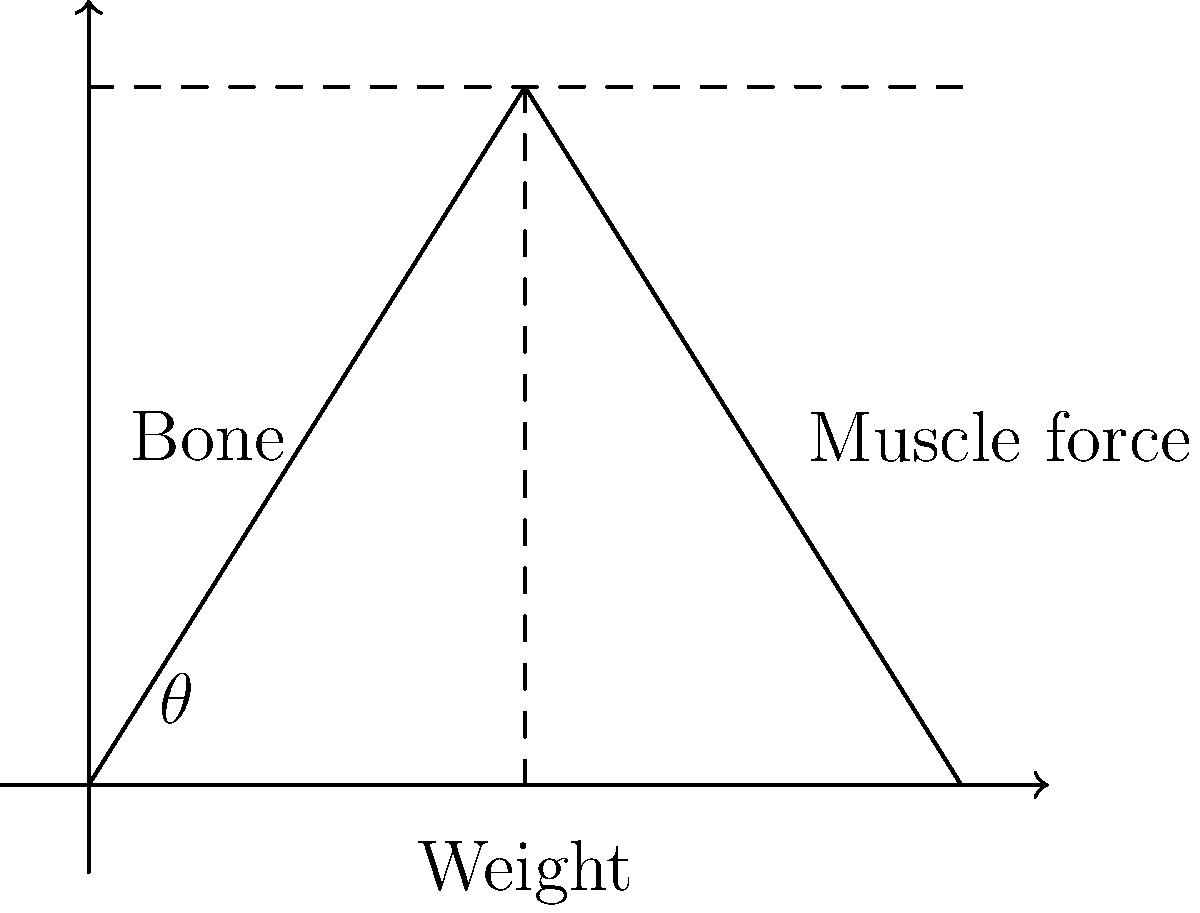In the diagram, a simplified model of a bone lifting a weight is shown. The bone forms an angle $\theta$ with the horizontal. If the weight being lifted is 50 N and the angle $\theta$ is 30°, what is the compressive force acting along the bone? Let's approach this step-by-step:

1) First, we need to understand that the bone experiences a compressive force along its length due to the weight and the muscle force.

2) The weight force (50 N) acts vertically downward.

3) To find the force along the bone, we need to resolve the weight force into components parallel and perpendicular to the bone.

4) The component of the weight force parallel to the bone will be the compressive force we're looking for.

5) We can use trigonometry to find this component:
   
   Compressive Force = Weight × cos(90° - θ)

6) We know that θ = 30°, so (90° - θ) = 60°

7) Therefore:
   
   Compressive Force = 50 N × cos(60°)

8) cos(60°) = 0.5

9) So, Compressive Force = 50 N × 0.5 = 25 N

Therefore, the compressive force acting along the bone is 25 N.
Answer: 25 N 